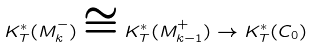<formula> <loc_0><loc_0><loc_500><loc_500>K _ { T } ^ { \ast } ( M _ { k } ^ { - } ) \cong K _ { T } ^ { \ast } ( M _ { k - 1 } ^ { + } ) \rightarrow K _ { T } ^ { \ast } ( C _ { 0 } )</formula> 